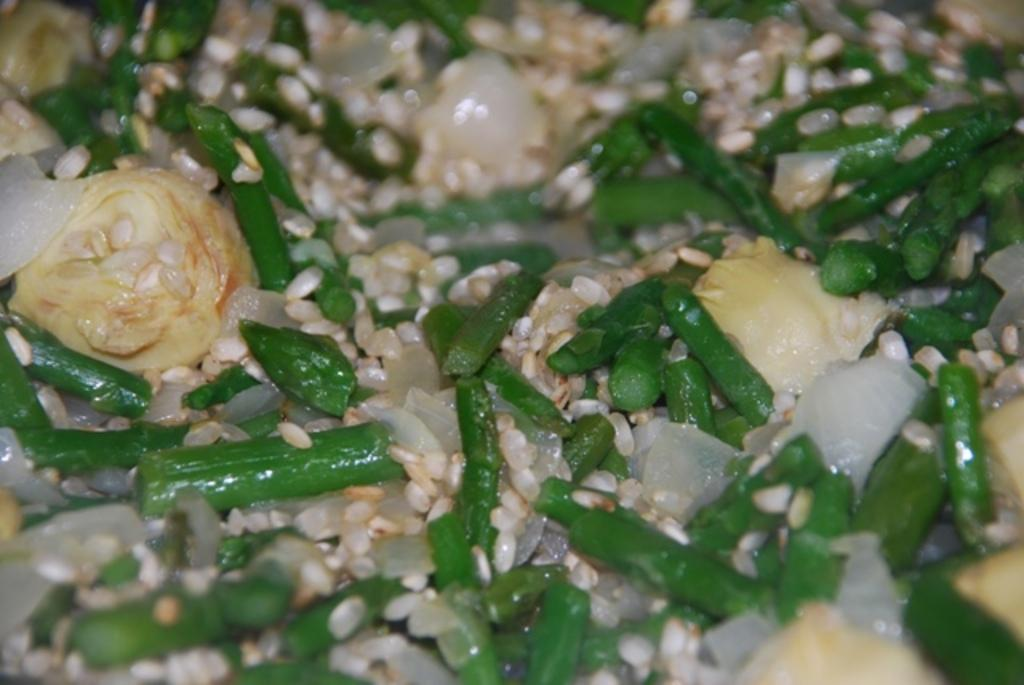What is the main subject of the picture? The main subject of the picture is food. Can you describe the appearance of the food? The food has cream and green colors. What type of jeans can be seen in the picture? There are no jeans present in the picture; it features food with cream and green colors. 